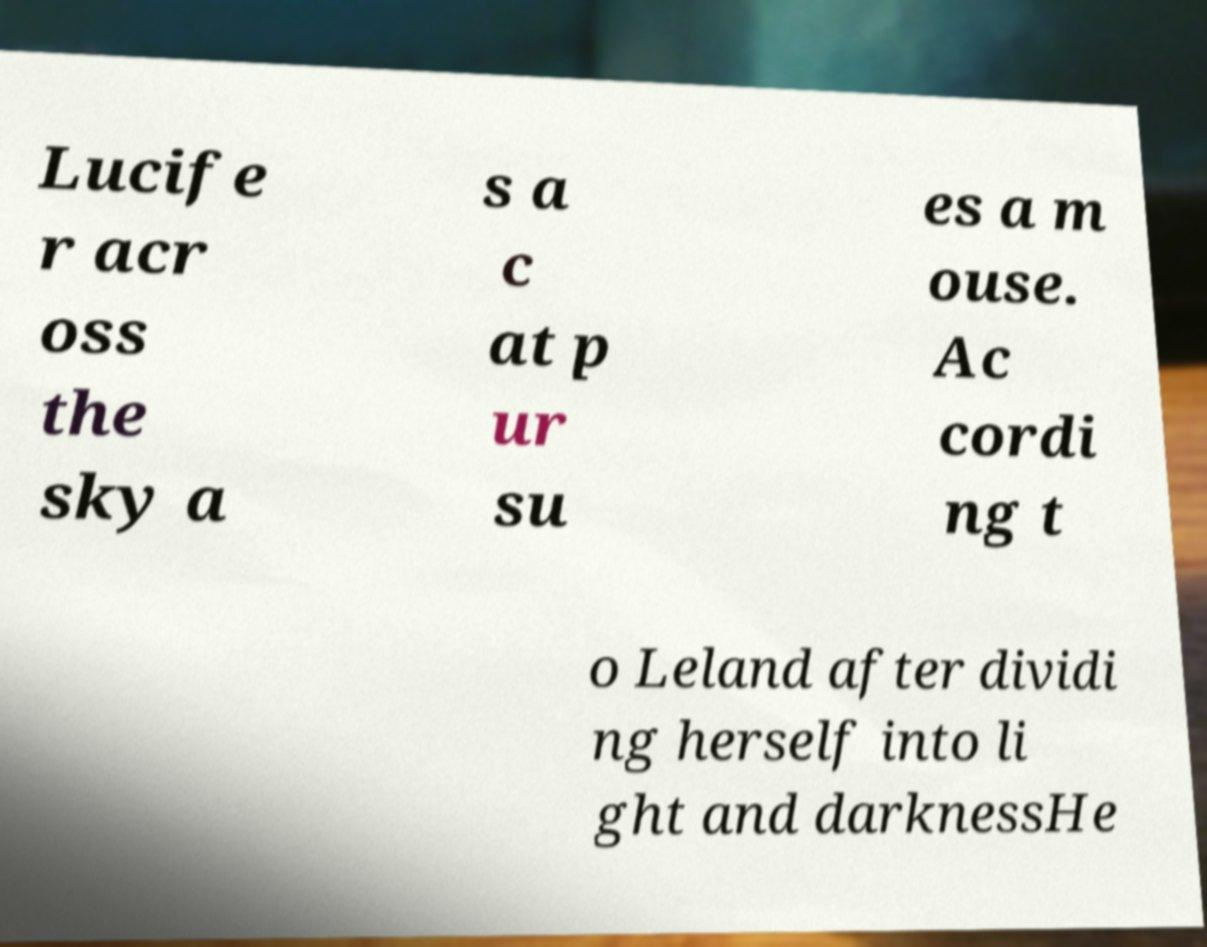There's text embedded in this image that I need extracted. Can you transcribe it verbatim? Lucife r acr oss the sky a s a c at p ur su es a m ouse. Ac cordi ng t o Leland after dividi ng herself into li ght and darknessHe 